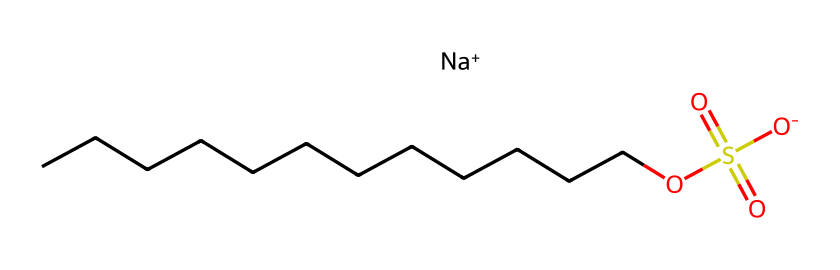What is the name of this chemical? The chemical structure corresponds to sodium dodecyl sulfate, which is indicated by its systematic name, sodium dodecyl sulfate or SDS. It can be identified by noting the presence of a sodium cation and the dodecyl group in the structure.
Answer: sodium dodecyl sulfate How many carbon atoms are in the long chain? The chemical structure shows a carbon chain denoted by "CCCCCCCCCCCC," which represents 12 carbon atoms (dodecyl group). This is confirmed by counting the number of "C" symbols in the chain.
Answer: 12 What does the "Na+" represent in the structure? The "Na+" in the structure represents a sodium ion, which indicates that this compound is a sodium salt of the corresponding acid (sulfate in this case). Sodium ions are commonly found in surfactants to enhance solubility in water.
Answer: sodium ion Which functional group is present in sodium dodecyl sulfate? The presence of "S(=O)(=O)O" indicates the sulfate functional group. The sulfur atom is bonded to oxygen with double bonds (indicating a sulfonate) and a single bond to an -O group. This shows that the chemical has characteristics typical of surfactants.
Answer: sulfate What is the role of the long hydrocarbon chain in this surfactant? The long hydrocarbon chain (12 carbon atoms) interacts with non-polar substances, allowing the surfactant to reduce surface tension and enable the mixing of oil and water. The hydrophobic tail is crucial for the function of surfactants in cleaning applications.
Answer: hydrophobic tail What is the charge of the sulfate group in sodium dodecyl sulfate? The sulfate group, indicated by "S(=O)(=O)O," carries a negative charge due to the presence of a double bond and a single bond to negatively charged oxygens. This charge helps the surfactant to interact with water, making it effective for cleaning.
Answer: negative charge 